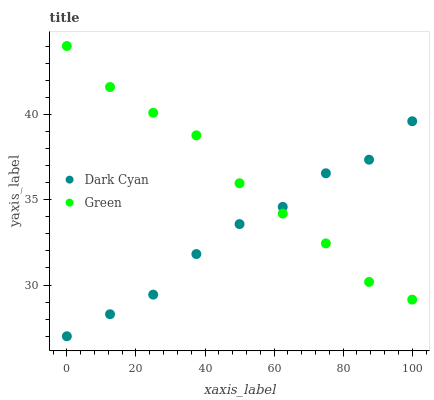Does Dark Cyan have the minimum area under the curve?
Answer yes or no. Yes. Does Green have the maximum area under the curve?
Answer yes or no. Yes. Does Green have the minimum area under the curve?
Answer yes or no. No. Is Green the smoothest?
Answer yes or no. Yes. Is Dark Cyan the roughest?
Answer yes or no. Yes. Is Green the roughest?
Answer yes or no. No. Does Dark Cyan have the lowest value?
Answer yes or no. Yes. Does Green have the lowest value?
Answer yes or no. No. Does Green have the highest value?
Answer yes or no. Yes. Does Green intersect Dark Cyan?
Answer yes or no. Yes. Is Green less than Dark Cyan?
Answer yes or no. No. Is Green greater than Dark Cyan?
Answer yes or no. No. 